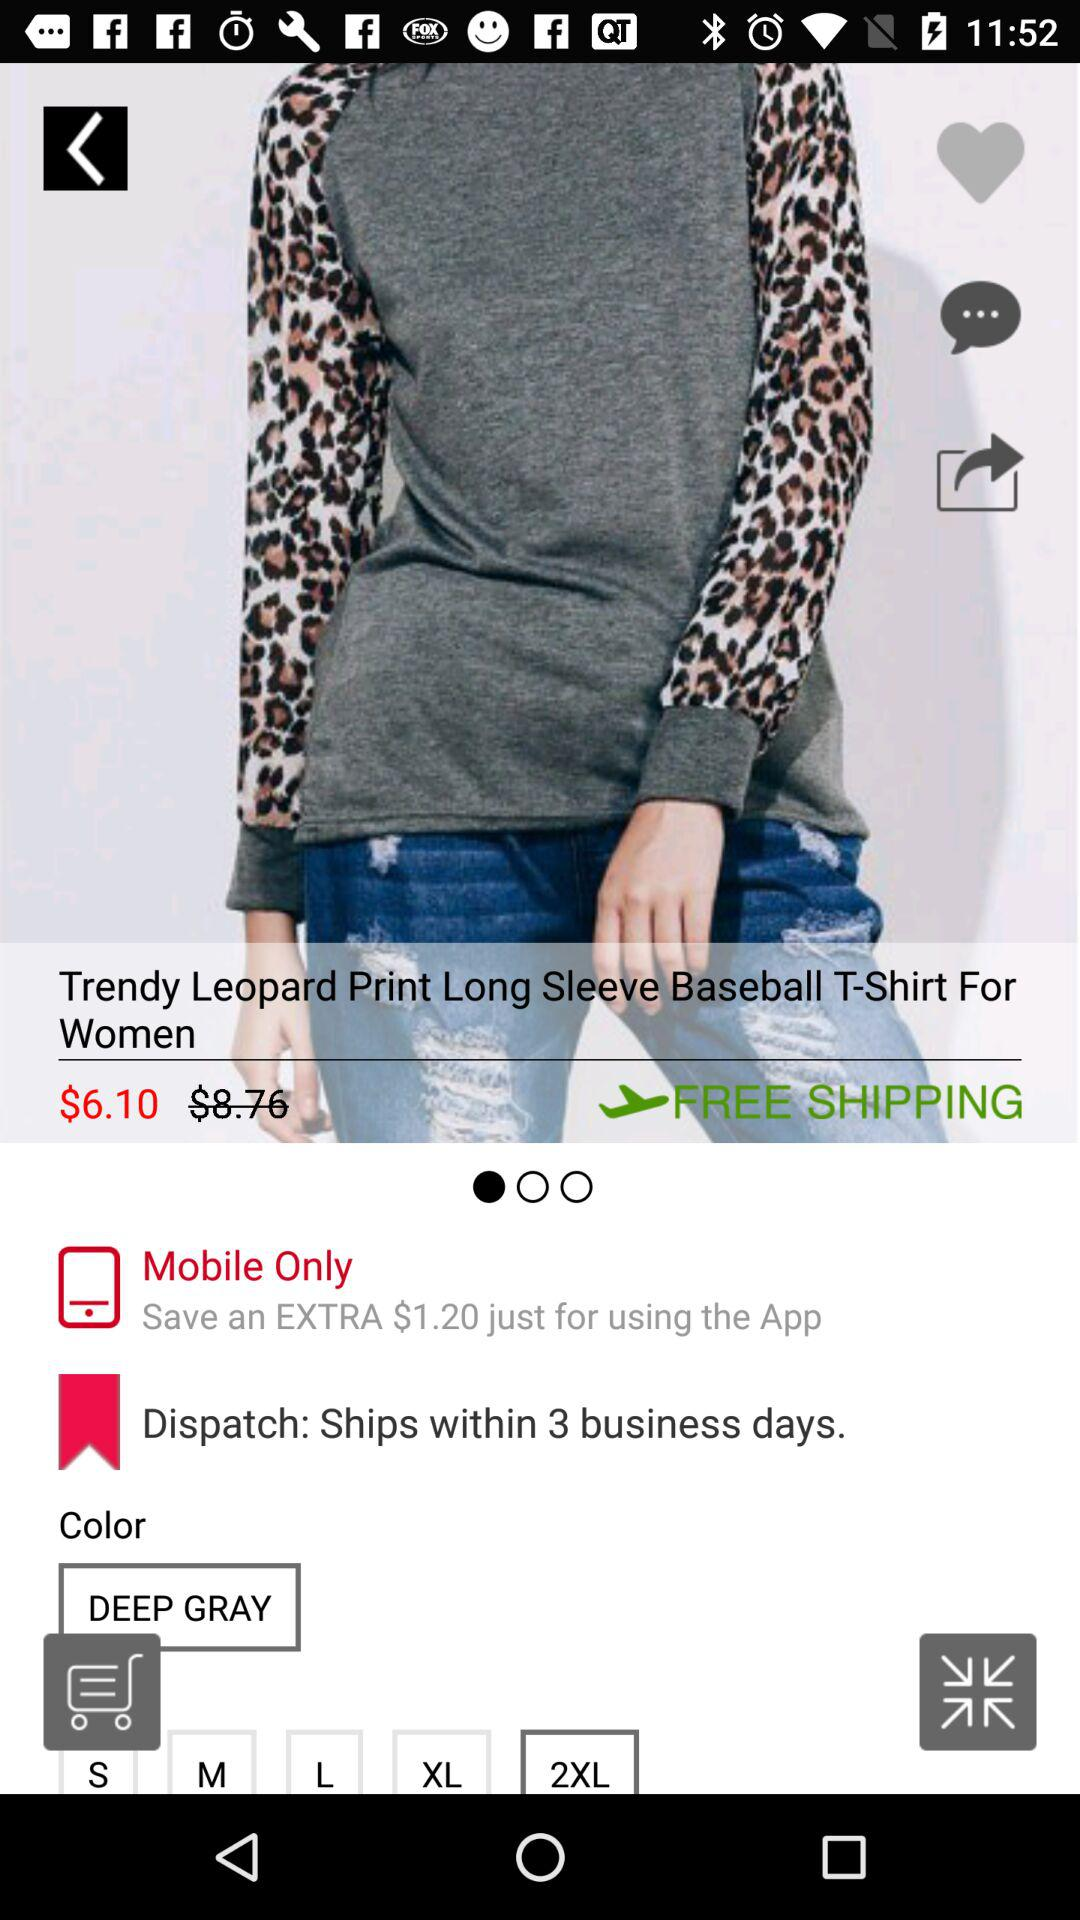How long will it take to ship? Shipping will be done within 3 business days. 